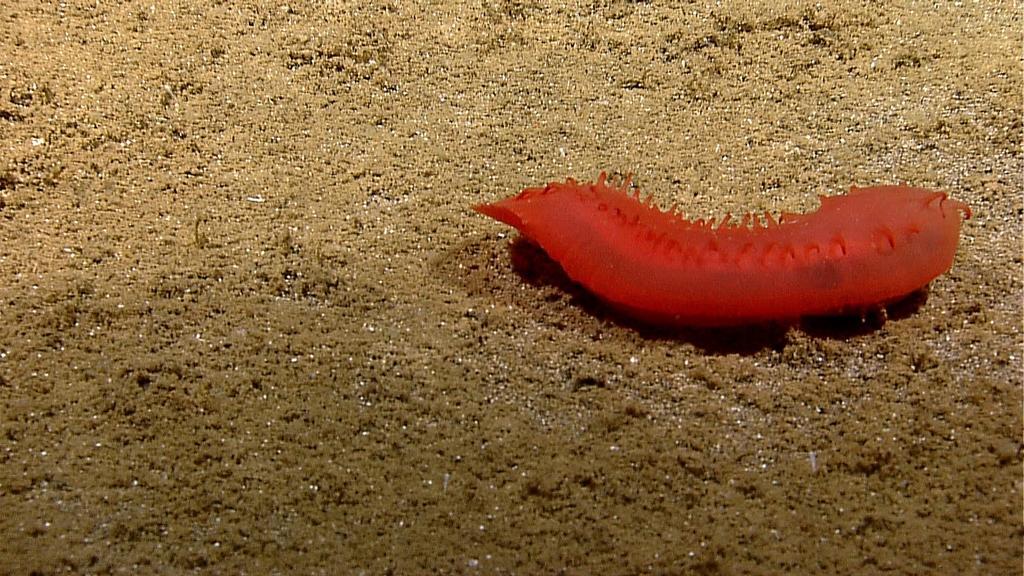Could you give a brief overview of what you see in this image? In the picture I can see an orange color insect on the ground. 